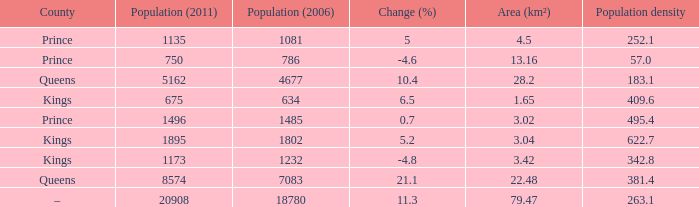In the County of Prince, what was the highest Population density when the Area (km²) was larger than 3.02, and the Population (2006) was larger than 786, and the Population (2011) was smaller than 1135? None. 